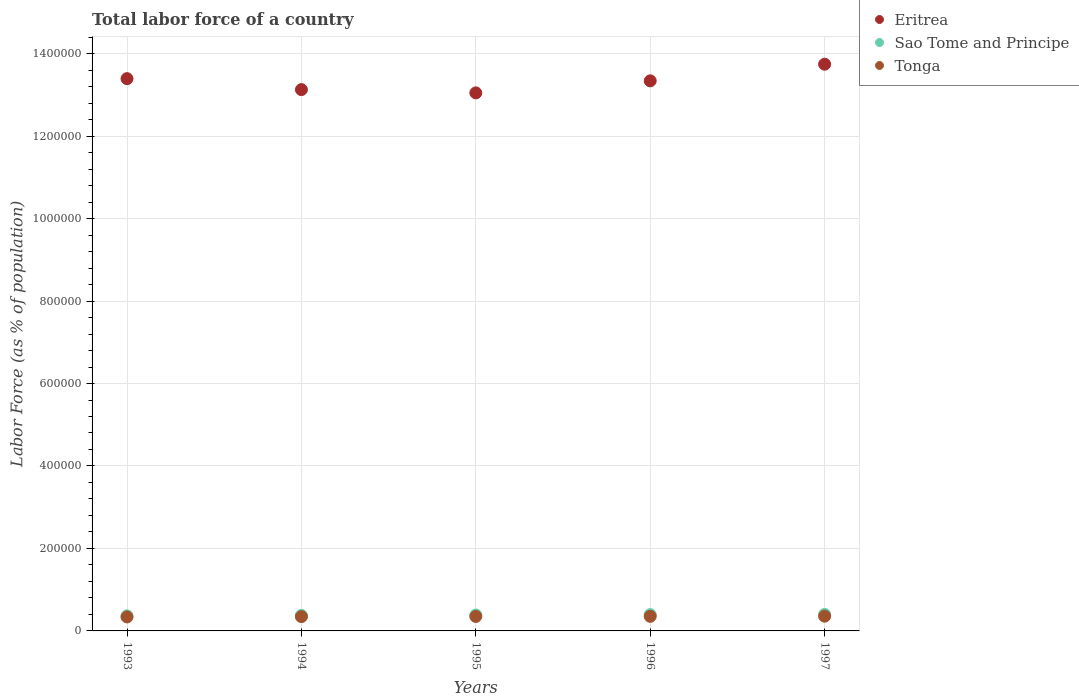How many different coloured dotlines are there?
Make the answer very short. 3. Is the number of dotlines equal to the number of legend labels?
Ensure brevity in your answer.  Yes. What is the percentage of labor force in Eritrea in 1995?
Keep it short and to the point. 1.30e+06. Across all years, what is the maximum percentage of labor force in Sao Tome and Principe?
Provide a succinct answer. 4.01e+04. Across all years, what is the minimum percentage of labor force in Tonga?
Ensure brevity in your answer.  3.39e+04. In which year was the percentage of labor force in Tonga minimum?
Offer a terse response. 1993. What is the total percentage of labor force in Eritrea in the graph?
Keep it short and to the point. 6.67e+06. What is the difference between the percentage of labor force in Sao Tome and Principe in 1996 and that in 1997?
Provide a succinct answer. -503. What is the difference between the percentage of labor force in Sao Tome and Principe in 1995 and the percentage of labor force in Tonga in 1996?
Make the answer very short. 3306. What is the average percentage of labor force in Tonga per year?
Give a very brief answer. 3.49e+04. In the year 1995, what is the difference between the percentage of labor force in Tonga and percentage of labor force in Eritrea?
Your answer should be very brief. -1.27e+06. What is the ratio of the percentage of labor force in Eritrea in 1993 to that in 1994?
Provide a short and direct response. 1.02. Is the difference between the percentage of labor force in Tonga in 1996 and 1997 greater than the difference between the percentage of labor force in Eritrea in 1996 and 1997?
Provide a succinct answer. Yes. What is the difference between the highest and the second highest percentage of labor force in Tonga?
Your answer should be compact. 381. What is the difference between the highest and the lowest percentage of labor force in Tonga?
Make the answer very short. 1787. Is it the case that in every year, the sum of the percentage of labor force in Sao Tome and Principe and percentage of labor force in Tonga  is greater than the percentage of labor force in Eritrea?
Give a very brief answer. No. Is the percentage of labor force in Eritrea strictly less than the percentage of labor force in Tonga over the years?
Offer a very short reply. No. Does the graph contain any zero values?
Your answer should be very brief. No. Does the graph contain grids?
Offer a very short reply. Yes. Where does the legend appear in the graph?
Your answer should be very brief. Top right. What is the title of the graph?
Keep it short and to the point. Total labor force of a country. What is the label or title of the X-axis?
Offer a very short reply. Years. What is the label or title of the Y-axis?
Your response must be concise. Labor Force (as % of population). What is the Labor Force (as % of population) in Eritrea in 1993?
Your response must be concise. 1.34e+06. What is the Labor Force (as % of population) in Sao Tome and Principe in 1993?
Offer a terse response. 3.65e+04. What is the Labor Force (as % of population) of Tonga in 1993?
Your answer should be compact. 3.39e+04. What is the Labor Force (as % of population) of Eritrea in 1994?
Keep it short and to the point. 1.31e+06. What is the Labor Force (as % of population) of Sao Tome and Principe in 1994?
Keep it short and to the point. 3.77e+04. What is the Labor Force (as % of population) of Tonga in 1994?
Make the answer very short. 3.46e+04. What is the Labor Force (as % of population) in Eritrea in 1995?
Make the answer very short. 1.30e+06. What is the Labor Force (as % of population) in Sao Tome and Principe in 1995?
Your answer should be very brief. 3.87e+04. What is the Labor Force (as % of population) of Tonga in 1995?
Provide a succinct answer. 3.51e+04. What is the Labor Force (as % of population) of Eritrea in 1996?
Provide a succinct answer. 1.33e+06. What is the Labor Force (as % of population) of Sao Tome and Principe in 1996?
Make the answer very short. 3.96e+04. What is the Labor Force (as % of population) in Tonga in 1996?
Provide a short and direct response. 3.54e+04. What is the Labor Force (as % of population) of Eritrea in 1997?
Your answer should be very brief. 1.37e+06. What is the Labor Force (as % of population) in Sao Tome and Principe in 1997?
Your response must be concise. 4.01e+04. What is the Labor Force (as % of population) in Tonga in 1997?
Give a very brief answer. 3.57e+04. Across all years, what is the maximum Labor Force (as % of population) in Eritrea?
Give a very brief answer. 1.37e+06. Across all years, what is the maximum Labor Force (as % of population) of Sao Tome and Principe?
Give a very brief answer. 4.01e+04. Across all years, what is the maximum Labor Force (as % of population) in Tonga?
Provide a short and direct response. 3.57e+04. Across all years, what is the minimum Labor Force (as % of population) of Eritrea?
Give a very brief answer. 1.30e+06. Across all years, what is the minimum Labor Force (as % of population) of Sao Tome and Principe?
Your answer should be compact. 3.65e+04. Across all years, what is the minimum Labor Force (as % of population) of Tonga?
Offer a terse response. 3.39e+04. What is the total Labor Force (as % of population) in Eritrea in the graph?
Your answer should be compact. 6.67e+06. What is the total Labor Force (as % of population) in Sao Tome and Principe in the graph?
Give a very brief answer. 1.92e+05. What is the total Labor Force (as % of population) in Tonga in the graph?
Provide a short and direct response. 1.75e+05. What is the difference between the Labor Force (as % of population) in Eritrea in 1993 and that in 1994?
Give a very brief answer. 2.66e+04. What is the difference between the Labor Force (as % of population) of Sao Tome and Principe in 1993 and that in 1994?
Keep it short and to the point. -1190. What is the difference between the Labor Force (as % of population) in Tonga in 1993 and that in 1994?
Ensure brevity in your answer.  -672. What is the difference between the Labor Force (as % of population) in Eritrea in 1993 and that in 1995?
Your answer should be very brief. 3.45e+04. What is the difference between the Labor Force (as % of population) in Sao Tome and Principe in 1993 and that in 1995?
Offer a very short reply. -2166. What is the difference between the Labor Force (as % of population) of Tonga in 1993 and that in 1995?
Ensure brevity in your answer.  -1148. What is the difference between the Labor Force (as % of population) of Eritrea in 1993 and that in 1996?
Offer a very short reply. 5309. What is the difference between the Labor Force (as % of population) of Sao Tome and Principe in 1993 and that in 1996?
Give a very brief answer. -3071. What is the difference between the Labor Force (as % of population) of Tonga in 1993 and that in 1996?
Provide a succinct answer. -1406. What is the difference between the Labor Force (as % of population) of Eritrea in 1993 and that in 1997?
Keep it short and to the point. -3.50e+04. What is the difference between the Labor Force (as % of population) in Sao Tome and Principe in 1993 and that in 1997?
Your answer should be very brief. -3574. What is the difference between the Labor Force (as % of population) of Tonga in 1993 and that in 1997?
Keep it short and to the point. -1787. What is the difference between the Labor Force (as % of population) in Eritrea in 1994 and that in 1995?
Keep it short and to the point. 7946. What is the difference between the Labor Force (as % of population) in Sao Tome and Principe in 1994 and that in 1995?
Keep it short and to the point. -976. What is the difference between the Labor Force (as % of population) in Tonga in 1994 and that in 1995?
Your response must be concise. -476. What is the difference between the Labor Force (as % of population) of Eritrea in 1994 and that in 1996?
Ensure brevity in your answer.  -2.13e+04. What is the difference between the Labor Force (as % of population) of Sao Tome and Principe in 1994 and that in 1996?
Ensure brevity in your answer.  -1881. What is the difference between the Labor Force (as % of population) of Tonga in 1994 and that in 1996?
Provide a succinct answer. -734. What is the difference between the Labor Force (as % of population) in Eritrea in 1994 and that in 1997?
Offer a very short reply. -6.16e+04. What is the difference between the Labor Force (as % of population) in Sao Tome and Principe in 1994 and that in 1997?
Your answer should be very brief. -2384. What is the difference between the Labor Force (as % of population) in Tonga in 1994 and that in 1997?
Offer a terse response. -1115. What is the difference between the Labor Force (as % of population) in Eritrea in 1995 and that in 1996?
Provide a succinct answer. -2.92e+04. What is the difference between the Labor Force (as % of population) in Sao Tome and Principe in 1995 and that in 1996?
Offer a very short reply. -905. What is the difference between the Labor Force (as % of population) in Tonga in 1995 and that in 1996?
Offer a terse response. -258. What is the difference between the Labor Force (as % of population) of Eritrea in 1995 and that in 1997?
Offer a very short reply. -6.95e+04. What is the difference between the Labor Force (as % of population) of Sao Tome and Principe in 1995 and that in 1997?
Keep it short and to the point. -1408. What is the difference between the Labor Force (as % of population) of Tonga in 1995 and that in 1997?
Your response must be concise. -639. What is the difference between the Labor Force (as % of population) of Eritrea in 1996 and that in 1997?
Your answer should be compact. -4.03e+04. What is the difference between the Labor Force (as % of population) in Sao Tome and Principe in 1996 and that in 1997?
Offer a terse response. -503. What is the difference between the Labor Force (as % of population) of Tonga in 1996 and that in 1997?
Provide a short and direct response. -381. What is the difference between the Labor Force (as % of population) in Eritrea in 1993 and the Labor Force (as % of population) in Sao Tome and Principe in 1994?
Your response must be concise. 1.30e+06. What is the difference between the Labor Force (as % of population) of Eritrea in 1993 and the Labor Force (as % of population) of Tonga in 1994?
Provide a succinct answer. 1.30e+06. What is the difference between the Labor Force (as % of population) of Sao Tome and Principe in 1993 and the Labor Force (as % of population) of Tonga in 1994?
Ensure brevity in your answer.  1874. What is the difference between the Labor Force (as % of population) in Eritrea in 1993 and the Labor Force (as % of population) in Sao Tome and Principe in 1995?
Your answer should be very brief. 1.30e+06. What is the difference between the Labor Force (as % of population) in Eritrea in 1993 and the Labor Force (as % of population) in Tonga in 1995?
Keep it short and to the point. 1.30e+06. What is the difference between the Labor Force (as % of population) in Sao Tome and Principe in 1993 and the Labor Force (as % of population) in Tonga in 1995?
Your answer should be very brief. 1398. What is the difference between the Labor Force (as % of population) in Eritrea in 1993 and the Labor Force (as % of population) in Sao Tome and Principe in 1996?
Provide a succinct answer. 1.30e+06. What is the difference between the Labor Force (as % of population) in Eritrea in 1993 and the Labor Force (as % of population) in Tonga in 1996?
Your answer should be very brief. 1.30e+06. What is the difference between the Labor Force (as % of population) of Sao Tome and Principe in 1993 and the Labor Force (as % of population) of Tonga in 1996?
Ensure brevity in your answer.  1140. What is the difference between the Labor Force (as % of population) in Eritrea in 1993 and the Labor Force (as % of population) in Sao Tome and Principe in 1997?
Provide a succinct answer. 1.30e+06. What is the difference between the Labor Force (as % of population) in Eritrea in 1993 and the Labor Force (as % of population) in Tonga in 1997?
Provide a succinct answer. 1.30e+06. What is the difference between the Labor Force (as % of population) of Sao Tome and Principe in 1993 and the Labor Force (as % of population) of Tonga in 1997?
Offer a very short reply. 759. What is the difference between the Labor Force (as % of population) in Eritrea in 1994 and the Labor Force (as % of population) in Sao Tome and Principe in 1995?
Your answer should be very brief. 1.27e+06. What is the difference between the Labor Force (as % of population) in Eritrea in 1994 and the Labor Force (as % of population) in Tonga in 1995?
Your answer should be very brief. 1.28e+06. What is the difference between the Labor Force (as % of population) in Sao Tome and Principe in 1994 and the Labor Force (as % of population) in Tonga in 1995?
Keep it short and to the point. 2588. What is the difference between the Labor Force (as % of population) of Eritrea in 1994 and the Labor Force (as % of population) of Sao Tome and Principe in 1996?
Make the answer very short. 1.27e+06. What is the difference between the Labor Force (as % of population) in Eritrea in 1994 and the Labor Force (as % of population) in Tonga in 1996?
Offer a terse response. 1.28e+06. What is the difference between the Labor Force (as % of population) in Sao Tome and Principe in 1994 and the Labor Force (as % of population) in Tonga in 1996?
Provide a succinct answer. 2330. What is the difference between the Labor Force (as % of population) in Eritrea in 1994 and the Labor Force (as % of population) in Sao Tome and Principe in 1997?
Your answer should be compact. 1.27e+06. What is the difference between the Labor Force (as % of population) of Eritrea in 1994 and the Labor Force (as % of population) of Tonga in 1997?
Give a very brief answer. 1.28e+06. What is the difference between the Labor Force (as % of population) of Sao Tome and Principe in 1994 and the Labor Force (as % of population) of Tonga in 1997?
Offer a very short reply. 1949. What is the difference between the Labor Force (as % of population) of Eritrea in 1995 and the Labor Force (as % of population) of Sao Tome and Principe in 1996?
Make the answer very short. 1.27e+06. What is the difference between the Labor Force (as % of population) of Eritrea in 1995 and the Labor Force (as % of population) of Tonga in 1996?
Your answer should be very brief. 1.27e+06. What is the difference between the Labor Force (as % of population) in Sao Tome and Principe in 1995 and the Labor Force (as % of population) in Tonga in 1996?
Offer a terse response. 3306. What is the difference between the Labor Force (as % of population) of Eritrea in 1995 and the Labor Force (as % of population) of Sao Tome and Principe in 1997?
Provide a succinct answer. 1.26e+06. What is the difference between the Labor Force (as % of population) in Eritrea in 1995 and the Labor Force (as % of population) in Tonga in 1997?
Offer a terse response. 1.27e+06. What is the difference between the Labor Force (as % of population) in Sao Tome and Principe in 1995 and the Labor Force (as % of population) in Tonga in 1997?
Offer a terse response. 2925. What is the difference between the Labor Force (as % of population) of Eritrea in 1996 and the Labor Force (as % of population) of Sao Tome and Principe in 1997?
Keep it short and to the point. 1.29e+06. What is the difference between the Labor Force (as % of population) of Eritrea in 1996 and the Labor Force (as % of population) of Tonga in 1997?
Your answer should be very brief. 1.30e+06. What is the difference between the Labor Force (as % of population) of Sao Tome and Principe in 1996 and the Labor Force (as % of population) of Tonga in 1997?
Provide a short and direct response. 3830. What is the average Labor Force (as % of population) in Eritrea per year?
Your answer should be compact. 1.33e+06. What is the average Labor Force (as % of population) in Sao Tome and Principe per year?
Your response must be concise. 3.85e+04. What is the average Labor Force (as % of population) in Tonga per year?
Keep it short and to the point. 3.49e+04. In the year 1993, what is the difference between the Labor Force (as % of population) of Eritrea and Labor Force (as % of population) of Sao Tome and Principe?
Give a very brief answer. 1.30e+06. In the year 1993, what is the difference between the Labor Force (as % of population) in Eritrea and Labor Force (as % of population) in Tonga?
Your answer should be very brief. 1.31e+06. In the year 1993, what is the difference between the Labor Force (as % of population) in Sao Tome and Principe and Labor Force (as % of population) in Tonga?
Your answer should be very brief. 2546. In the year 1994, what is the difference between the Labor Force (as % of population) in Eritrea and Labor Force (as % of population) in Sao Tome and Principe?
Offer a terse response. 1.28e+06. In the year 1994, what is the difference between the Labor Force (as % of population) of Eritrea and Labor Force (as % of population) of Tonga?
Your response must be concise. 1.28e+06. In the year 1994, what is the difference between the Labor Force (as % of population) in Sao Tome and Principe and Labor Force (as % of population) in Tonga?
Offer a terse response. 3064. In the year 1995, what is the difference between the Labor Force (as % of population) in Eritrea and Labor Force (as % of population) in Sao Tome and Principe?
Provide a short and direct response. 1.27e+06. In the year 1995, what is the difference between the Labor Force (as % of population) in Eritrea and Labor Force (as % of population) in Tonga?
Your response must be concise. 1.27e+06. In the year 1995, what is the difference between the Labor Force (as % of population) in Sao Tome and Principe and Labor Force (as % of population) in Tonga?
Give a very brief answer. 3564. In the year 1996, what is the difference between the Labor Force (as % of population) of Eritrea and Labor Force (as % of population) of Sao Tome and Principe?
Your answer should be very brief. 1.29e+06. In the year 1996, what is the difference between the Labor Force (as % of population) of Eritrea and Labor Force (as % of population) of Tonga?
Offer a very short reply. 1.30e+06. In the year 1996, what is the difference between the Labor Force (as % of population) in Sao Tome and Principe and Labor Force (as % of population) in Tonga?
Ensure brevity in your answer.  4211. In the year 1997, what is the difference between the Labor Force (as % of population) of Eritrea and Labor Force (as % of population) of Sao Tome and Principe?
Offer a very short reply. 1.33e+06. In the year 1997, what is the difference between the Labor Force (as % of population) of Eritrea and Labor Force (as % of population) of Tonga?
Keep it short and to the point. 1.34e+06. In the year 1997, what is the difference between the Labor Force (as % of population) of Sao Tome and Principe and Labor Force (as % of population) of Tonga?
Ensure brevity in your answer.  4333. What is the ratio of the Labor Force (as % of population) of Eritrea in 1993 to that in 1994?
Offer a very short reply. 1.02. What is the ratio of the Labor Force (as % of population) in Sao Tome and Principe in 1993 to that in 1994?
Provide a short and direct response. 0.97. What is the ratio of the Labor Force (as % of population) of Tonga in 1993 to that in 1994?
Provide a succinct answer. 0.98. What is the ratio of the Labor Force (as % of population) of Eritrea in 1993 to that in 1995?
Make the answer very short. 1.03. What is the ratio of the Labor Force (as % of population) in Sao Tome and Principe in 1993 to that in 1995?
Your response must be concise. 0.94. What is the ratio of the Labor Force (as % of population) in Tonga in 1993 to that in 1995?
Provide a succinct answer. 0.97. What is the ratio of the Labor Force (as % of population) in Sao Tome and Principe in 1993 to that in 1996?
Provide a short and direct response. 0.92. What is the ratio of the Labor Force (as % of population) of Tonga in 1993 to that in 1996?
Your response must be concise. 0.96. What is the ratio of the Labor Force (as % of population) of Eritrea in 1993 to that in 1997?
Offer a very short reply. 0.97. What is the ratio of the Labor Force (as % of population) of Sao Tome and Principe in 1993 to that in 1997?
Provide a short and direct response. 0.91. What is the ratio of the Labor Force (as % of population) of Sao Tome and Principe in 1994 to that in 1995?
Keep it short and to the point. 0.97. What is the ratio of the Labor Force (as % of population) in Tonga in 1994 to that in 1995?
Provide a succinct answer. 0.99. What is the ratio of the Labor Force (as % of population) of Eritrea in 1994 to that in 1996?
Offer a very short reply. 0.98. What is the ratio of the Labor Force (as % of population) of Sao Tome and Principe in 1994 to that in 1996?
Keep it short and to the point. 0.95. What is the ratio of the Labor Force (as % of population) in Tonga in 1994 to that in 1996?
Offer a terse response. 0.98. What is the ratio of the Labor Force (as % of population) in Eritrea in 1994 to that in 1997?
Your answer should be compact. 0.96. What is the ratio of the Labor Force (as % of population) of Sao Tome and Principe in 1994 to that in 1997?
Provide a short and direct response. 0.94. What is the ratio of the Labor Force (as % of population) in Tonga in 1994 to that in 1997?
Your answer should be compact. 0.97. What is the ratio of the Labor Force (as % of population) of Eritrea in 1995 to that in 1996?
Your answer should be very brief. 0.98. What is the ratio of the Labor Force (as % of population) of Sao Tome and Principe in 1995 to that in 1996?
Your answer should be very brief. 0.98. What is the ratio of the Labor Force (as % of population) of Tonga in 1995 to that in 1996?
Provide a short and direct response. 0.99. What is the ratio of the Labor Force (as % of population) in Eritrea in 1995 to that in 1997?
Make the answer very short. 0.95. What is the ratio of the Labor Force (as % of population) of Sao Tome and Principe in 1995 to that in 1997?
Offer a terse response. 0.96. What is the ratio of the Labor Force (as % of population) in Tonga in 1995 to that in 1997?
Make the answer very short. 0.98. What is the ratio of the Labor Force (as % of population) of Eritrea in 1996 to that in 1997?
Offer a very short reply. 0.97. What is the ratio of the Labor Force (as % of population) of Sao Tome and Principe in 1996 to that in 1997?
Your response must be concise. 0.99. What is the ratio of the Labor Force (as % of population) of Tonga in 1996 to that in 1997?
Make the answer very short. 0.99. What is the difference between the highest and the second highest Labor Force (as % of population) in Eritrea?
Offer a terse response. 3.50e+04. What is the difference between the highest and the second highest Labor Force (as % of population) of Sao Tome and Principe?
Give a very brief answer. 503. What is the difference between the highest and the second highest Labor Force (as % of population) of Tonga?
Your answer should be compact. 381. What is the difference between the highest and the lowest Labor Force (as % of population) of Eritrea?
Your answer should be very brief. 6.95e+04. What is the difference between the highest and the lowest Labor Force (as % of population) of Sao Tome and Principe?
Offer a terse response. 3574. What is the difference between the highest and the lowest Labor Force (as % of population) in Tonga?
Your answer should be compact. 1787. 